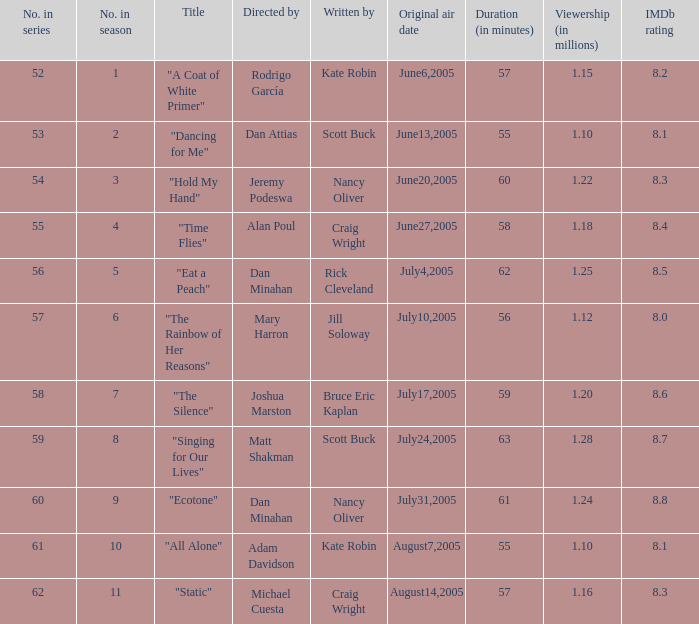What was the name of the episode that was directed by Mary Harron? "The Rainbow of Her Reasons". 